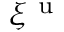Convert formula to latex. <formula><loc_0><loc_0><loc_500><loc_500>\xi ^ { u }</formula> 